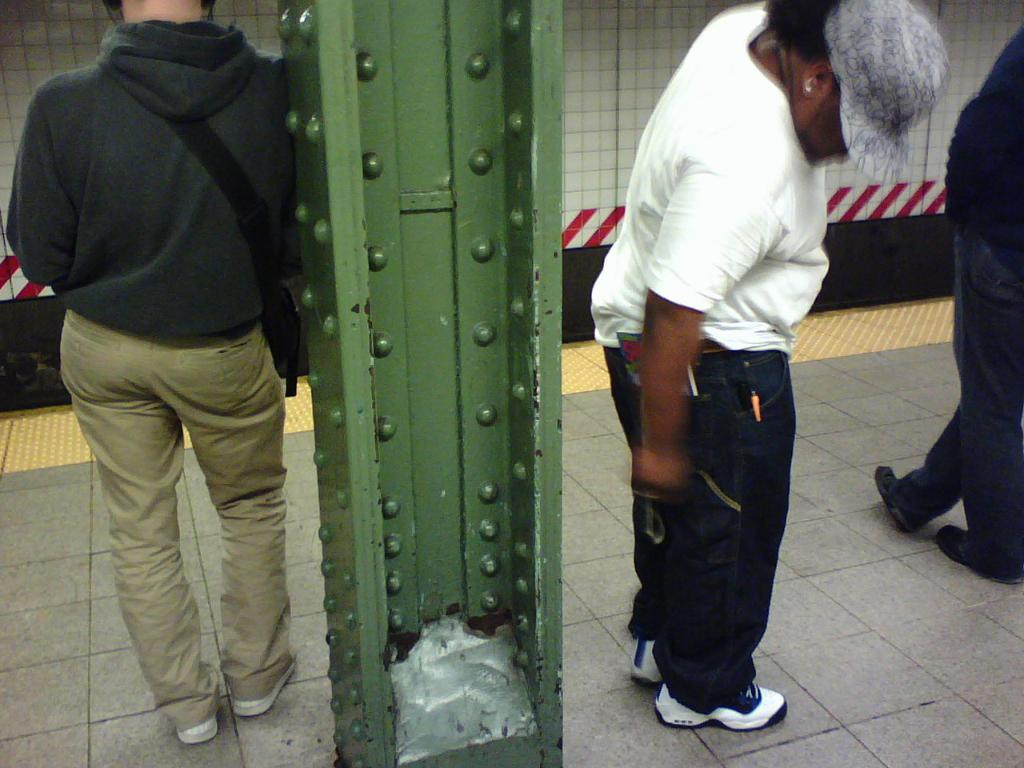What is the main focus of the image? The main focus of the image is the people in the center. What are some of the people doing in the image? Some people are standing in the image. What can be seen in the background of the image? There is a wall in the background of the image. What is at the bottom of the image? There is a floor at the bottom of the image. What type of waves can be seen crashing against the shore in the image? There are no waves present in the image; it features people and a wall in the background. Can you tell me how many train tracks are visible in the image? There are no train tracks present in the image. 